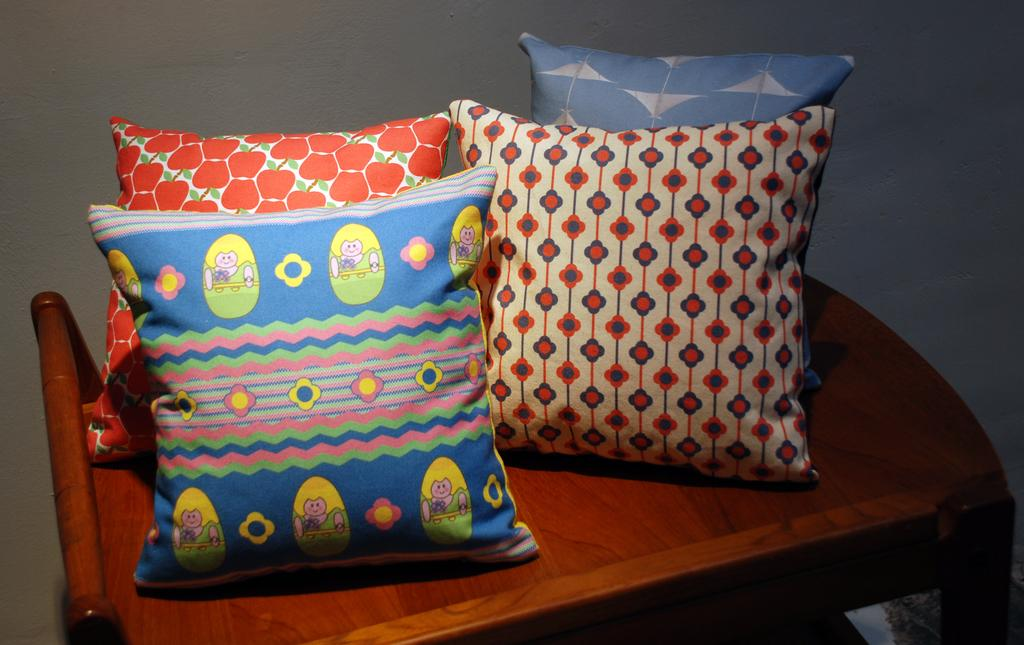What type of furniture is present in the image? There is a table in the image. How is the table depicted in the image? The table appears to be truncated towards the bottom of the image. What objects are placed on the table? There are four pillows on the table. What can be seen in the background of the image? There is a wall in the background of the image. Can you see the arm of the person sitting on the table in the image? There is no person sitting on the table in the image, so it is not possible to see their arm. What type of animal can be observed interacting with the pillows on the table in the image? There are no animals present in the image, so it is not possible to observe any interaction with the pillows. 